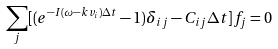Convert formula to latex. <formula><loc_0><loc_0><loc_500><loc_500>\sum _ { j } [ ( e ^ { - I ( \omega - k v _ { i } ) \Delta t } - 1 ) \delta _ { i j } - C _ { i j } \Delta t ] f _ { j } = 0</formula> 